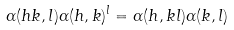<formula> <loc_0><loc_0><loc_500><loc_500>\alpha ( h k , l ) \alpha ( h , k ) ^ { l } = \alpha ( h , k l ) \alpha ( k , l )</formula> 